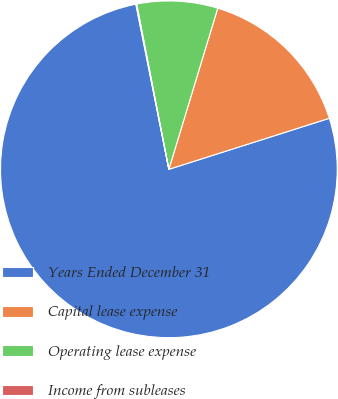Convert chart. <chart><loc_0><loc_0><loc_500><loc_500><pie_chart><fcel>Years Ended December 31<fcel>Capital lease expense<fcel>Operating lease expense<fcel>Income from subleases<nl><fcel>76.76%<fcel>15.41%<fcel>7.75%<fcel>0.08%<nl></chart> 